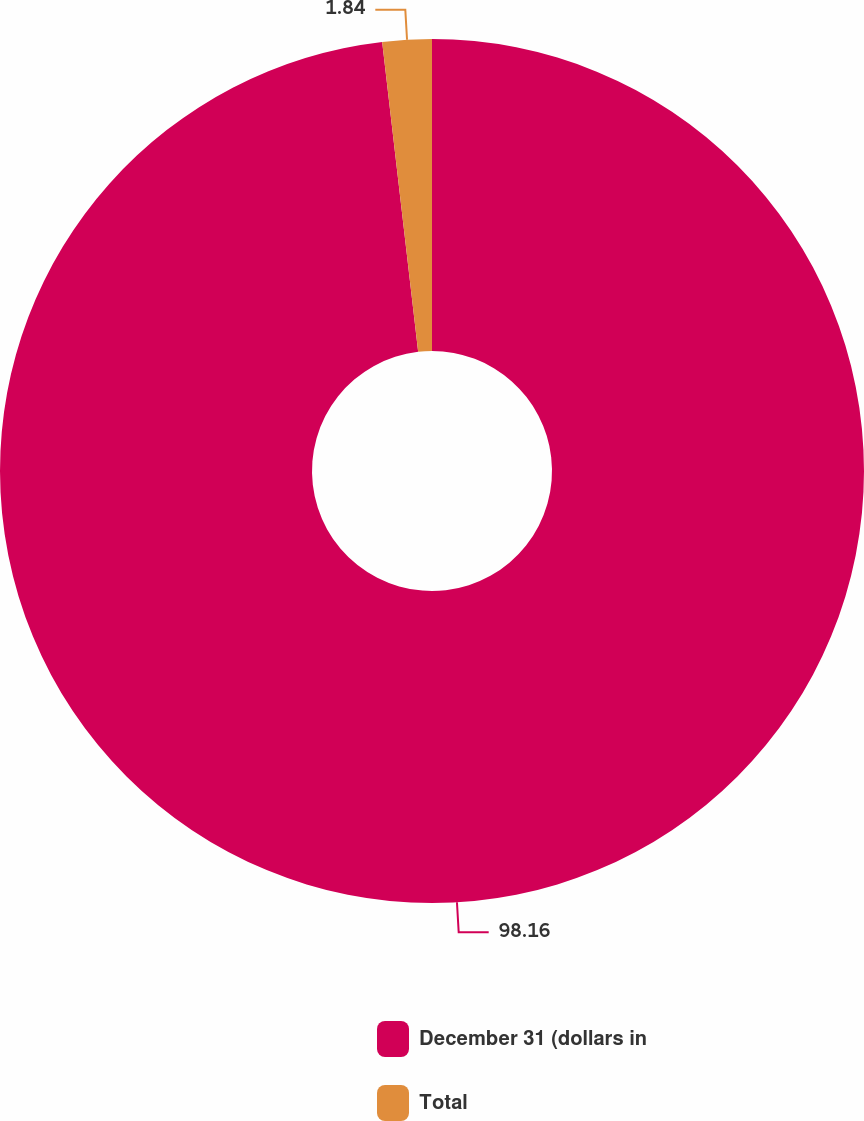Convert chart. <chart><loc_0><loc_0><loc_500><loc_500><pie_chart><fcel>December 31 (dollars in<fcel>Total<nl><fcel>98.16%<fcel>1.84%<nl></chart> 